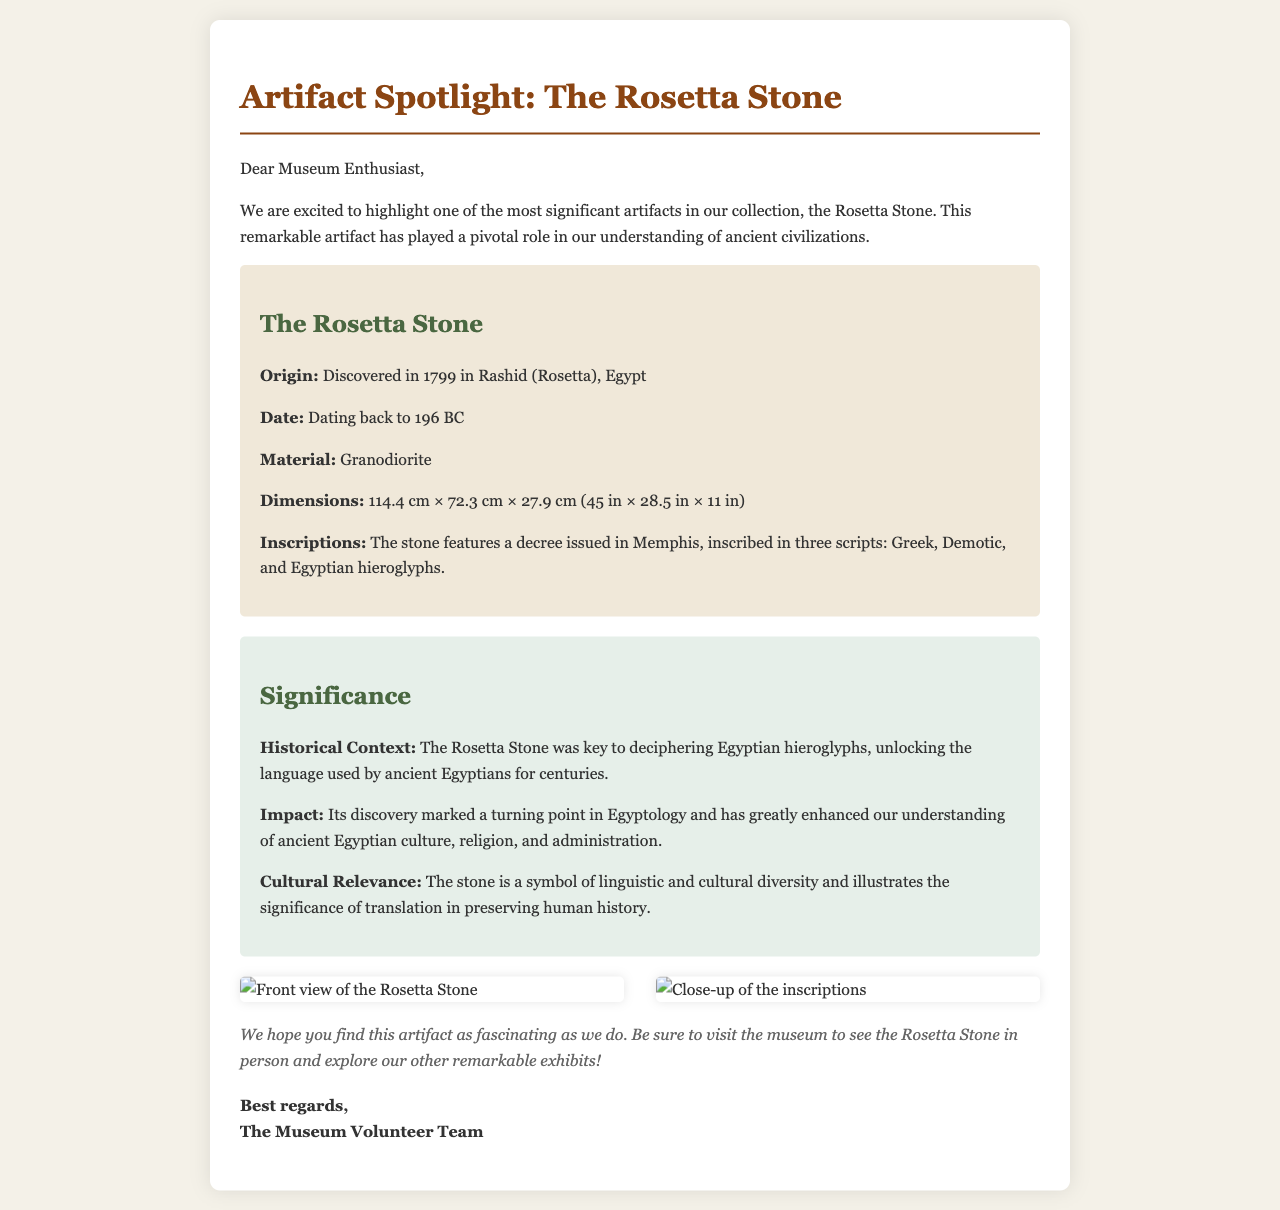What artifact is featured in this email? The email is showcasing the Rosetta Stone, which is indicated in the title and content.
Answer: The Rosetta Stone When was the Rosetta Stone discovered? The discovery date of the Rosetta Stone is provided in the document as 1799.
Answer: 1799 What material is the Rosetta Stone made of? The document mentions that the Rosetta Stone is made of granodiorite.
Answer: Granodiorite How many scripts are inscribed on the Rosetta Stone? The document states that there are three scripts on the Rosetta Stone: Greek, Demotic, and Egyptian hieroglyphs.
Answer: Three What is the significance of the Rosetta Stone in Egyptology? The document explains that the Rosetta Stone was key to deciphering Egyptian hieroglyphs, which marked a turning point in Egyptology.
Answer: Key to deciphering Egyptian hieroglyphs What are the dimensions of the Rosetta Stone? The dimensions are provided in the document as 114.4 cm × 72.3 cm × 27.9 cm.
Answer: 114.4 cm × 72.3 cm × 27.9 cm What is the cultural relevance of the Rosetta Stone? The document describes the Rosetta Stone as a symbol of linguistic and cultural diversity.
Answer: Symbol of linguistic and cultural diversity What kind of artifact is this email primarily showcasing? The email focuses on a historical artifact as indicated in the title and the content.
Answer: Historical artifact How does the email encourage the visitor? The closing section of the email encourages the visitor to explore the museum and see the artifact in person.
Answer: To explore the museum and see the artifact in person 